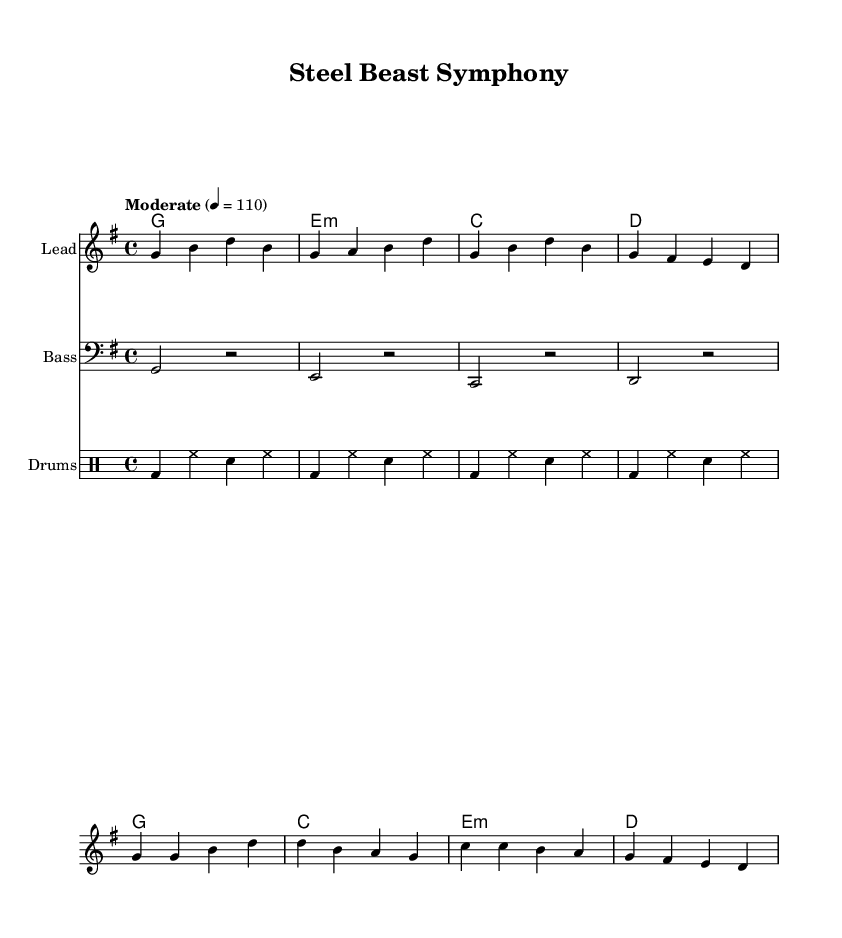What is the key signature of this music? The key signature is G major, which has one sharp (F#) as indicated at the beginning of the music sheet.
Answer: G major What is the time signature of this piece? The time signature is 4/4, which is displayed at the beginning of the score and indicates there are four beats in each measure.
Answer: 4/4 What is the tempo marking for this piece? The tempo marking is "Moderate" with a metronome marking of 110 beats per minute. This indicates the pace of the music.
Answer: Moderate, 110 How many measures are in the verse? The verse consists of 4 measures, as indicated by the grouping of notes and the structure that aligns with typical verse patterns in music.
Answer: 4 What type of instrument plays the melody in this score? The melody is played by the "Lead" instrument, which is typically a guitar or a similar melodic instrument in country rock music.
Answer: Lead What is the primary theme expressed in the lyrics? The primary theme revolves around the pride and hard work associated with operating heavy machinery, as revealed through the lyrics focused on steel and machinery.
Answer: Hard work and satisfaction How many times does the chorus repeat in the score? The chorus appears once in the score as it is typically stated without repetition here, unlike verses that could repeat in traditional song structures.
Answer: Once 